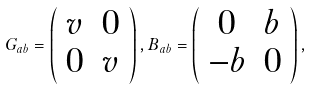<formula> <loc_0><loc_0><loc_500><loc_500>G _ { a b } = \left ( \begin{array} { c c } { v } & { 0 } \\ { 0 } & { v } \end{array} \right ) , B _ { a b } = \left ( \begin{array} { c c } { 0 } & { b } \\ { - b } & { 0 } \end{array} \right ) ,</formula> 